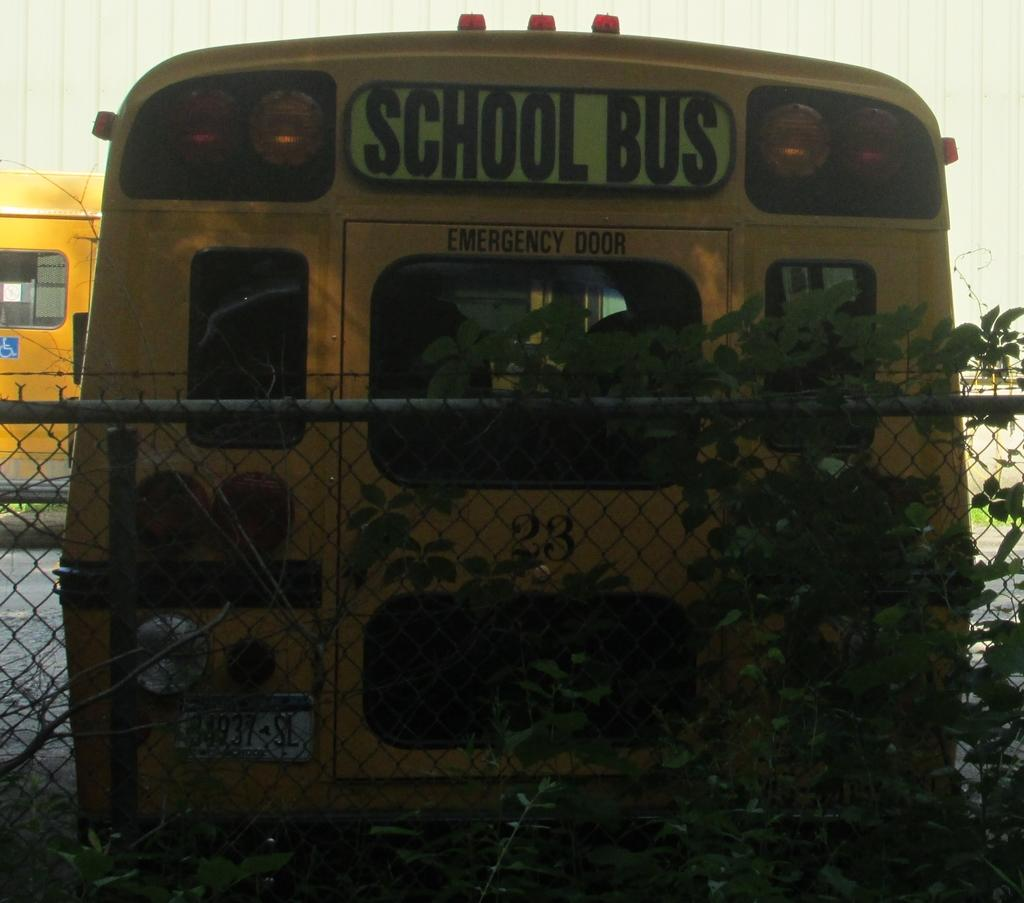<image>
Summarize the visual content of the image. A yellow bus with school bus written on it in front of  a fence 